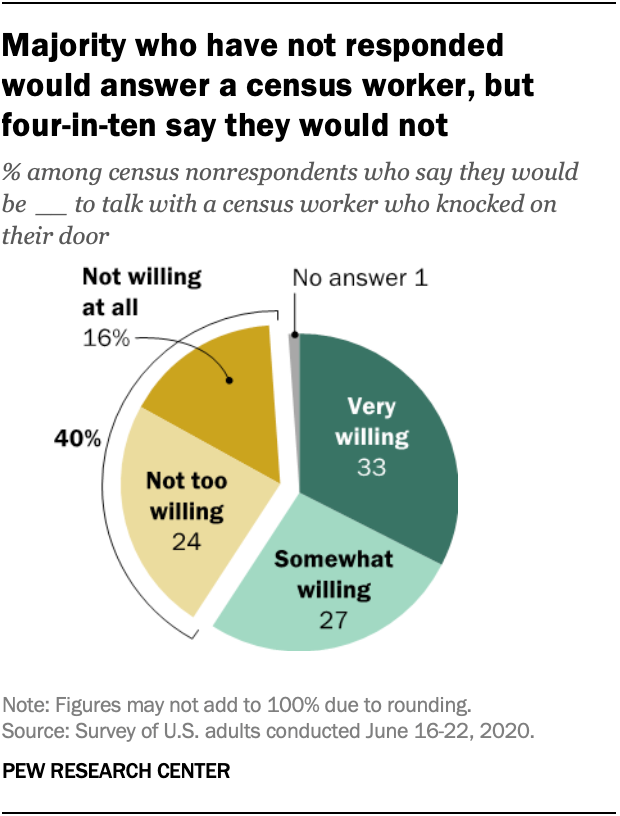Identify some key points in this picture. The difference between the smallest and largest segments is greater than the yellow segment. The color of the smallest bar is gray. 